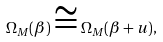Convert formula to latex. <formula><loc_0><loc_0><loc_500><loc_500>\Omega _ { M } ( \beta ) \cong \Omega _ { M } ( \beta + u ) ,</formula> 